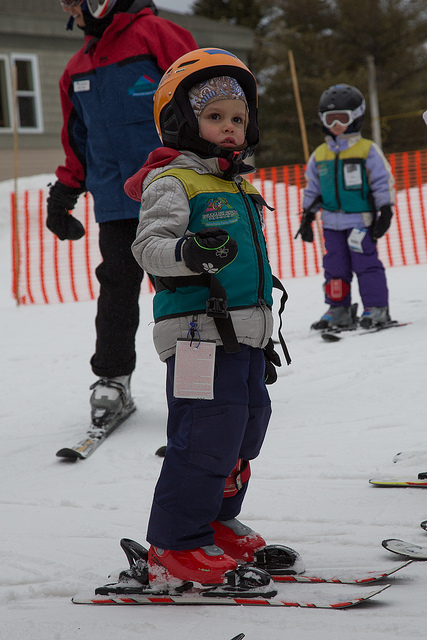<image>Where are there mother? It is unknown where their mother is. She could be between them, behind them, at home, in the middle, taking the photo, or beside them. Where are there mother? I don't know where their mother is. She can be either between them, behind them, at home, in the middle, beside them, or next to them. 